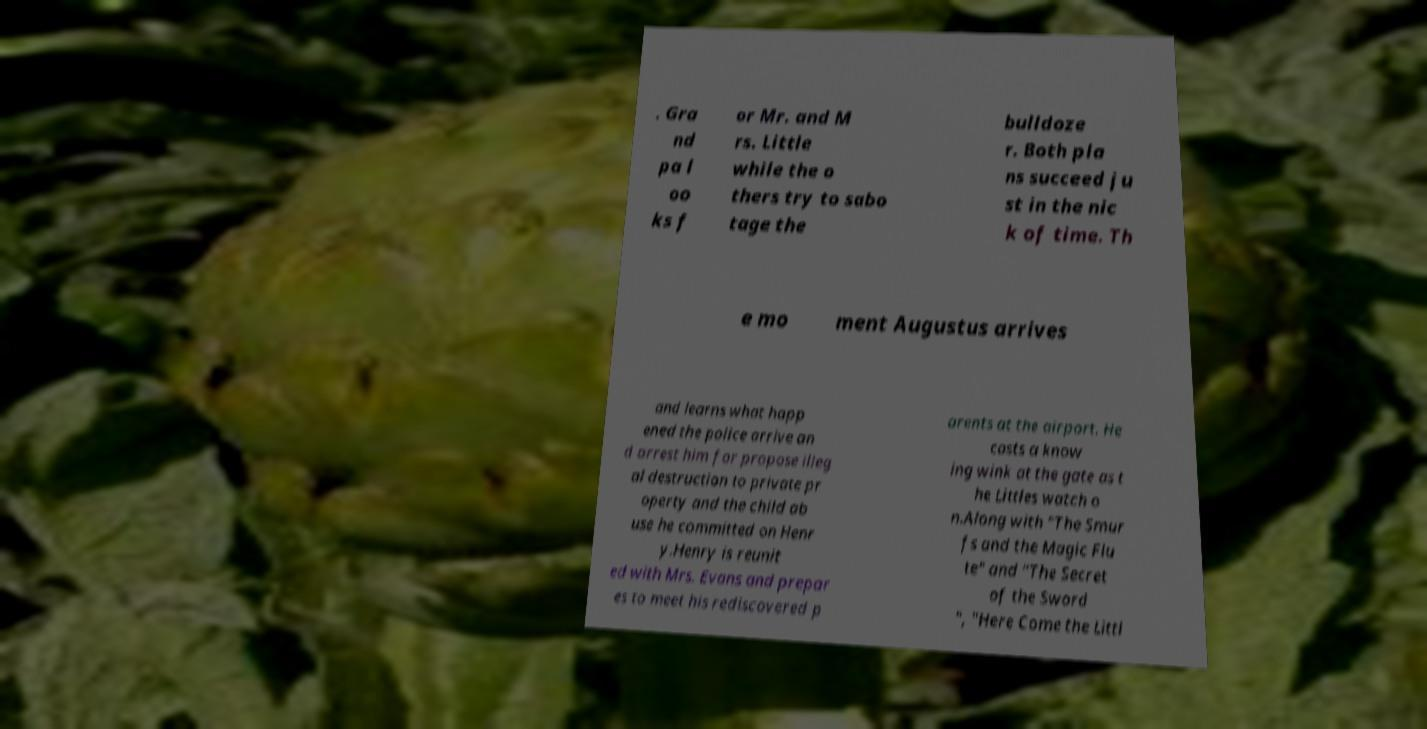For documentation purposes, I need the text within this image transcribed. Could you provide that? . Gra nd pa l oo ks f or Mr. and M rs. Little while the o thers try to sabo tage the bulldoze r. Both pla ns succeed ju st in the nic k of time. Th e mo ment Augustus arrives and learns what happ ened the police arrive an d arrest him for propose illeg al destruction to private pr operty and the child ab use he committed on Henr y.Henry is reunit ed with Mrs. Evans and prepar es to meet his rediscovered p arents at the airport. He casts a know ing wink at the gate as t he Littles watch o n.Along with "The Smur fs and the Magic Flu te" and "The Secret of the Sword ", "Here Come the Littl 